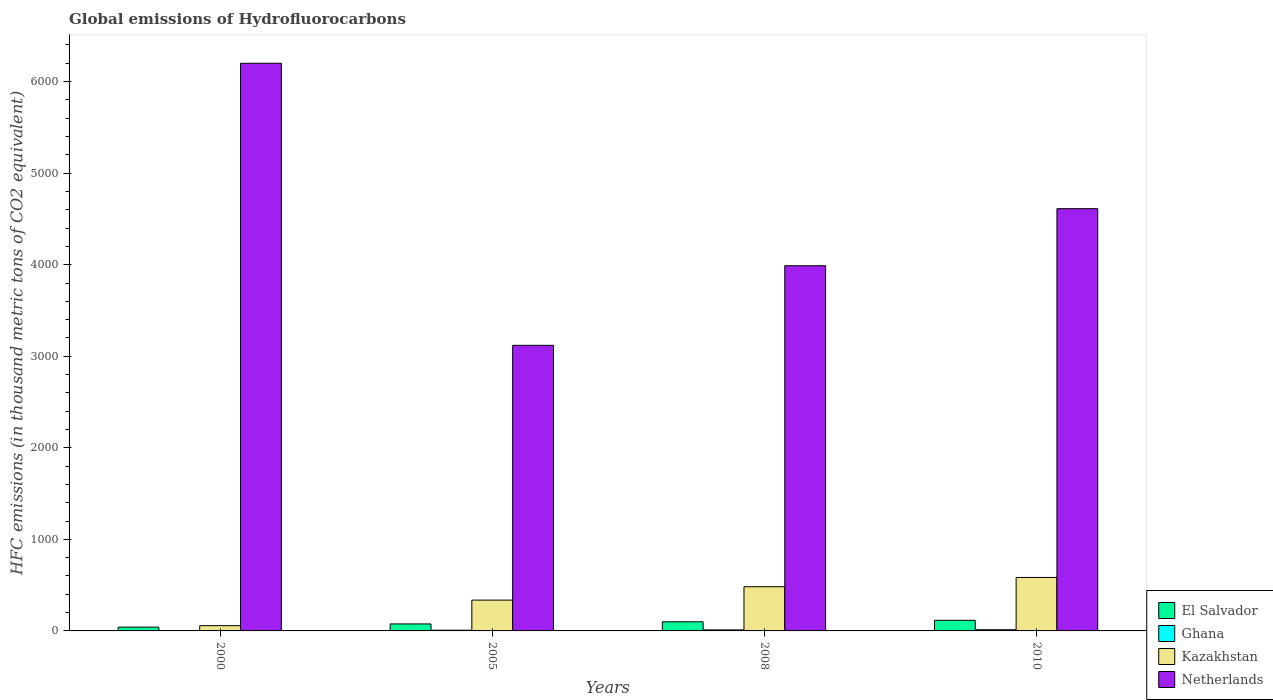How many groups of bars are there?
Offer a very short reply. 4. How many bars are there on the 4th tick from the left?
Give a very brief answer. 4. In how many cases, is the number of bars for a given year not equal to the number of legend labels?
Your answer should be very brief. 0. What is the global emissions of Hydrofluorocarbons in Netherlands in 2008?
Offer a terse response. 3988.8. Across all years, what is the minimum global emissions of Hydrofluorocarbons in El Salvador?
Your answer should be compact. 41.4. In which year was the global emissions of Hydrofluorocarbons in Kazakhstan minimum?
Provide a succinct answer. 2000. What is the total global emissions of Hydrofluorocarbons in Netherlands in the graph?
Make the answer very short. 1.79e+04. What is the difference between the global emissions of Hydrofluorocarbons in Netherlands in 2008 and that in 2010?
Keep it short and to the point. -623.2. What is the difference between the global emissions of Hydrofluorocarbons in Kazakhstan in 2000 and the global emissions of Hydrofluorocarbons in Netherlands in 2010?
Ensure brevity in your answer.  -4554.5. What is the average global emissions of Hydrofluorocarbons in Kazakhstan per year?
Ensure brevity in your answer.  365.27. In the year 2000, what is the difference between the global emissions of Hydrofluorocarbons in El Salvador and global emissions of Hydrofluorocarbons in Ghana?
Offer a terse response. 39.5. What is the ratio of the global emissions of Hydrofluorocarbons in Netherlands in 2008 to that in 2010?
Give a very brief answer. 0.86. Is the difference between the global emissions of Hydrofluorocarbons in El Salvador in 2005 and 2008 greater than the difference between the global emissions of Hydrofluorocarbons in Ghana in 2005 and 2008?
Ensure brevity in your answer.  No. What is the difference between the highest and the second highest global emissions of Hydrofluorocarbons in El Salvador?
Your answer should be very brief. 16.4. What is the difference between the highest and the lowest global emissions of Hydrofluorocarbons in Ghana?
Your response must be concise. 11.1. In how many years, is the global emissions of Hydrofluorocarbons in Kazakhstan greater than the average global emissions of Hydrofluorocarbons in Kazakhstan taken over all years?
Ensure brevity in your answer.  2. Is the sum of the global emissions of Hydrofluorocarbons in Ghana in 2000 and 2010 greater than the maximum global emissions of Hydrofluorocarbons in Netherlands across all years?
Your answer should be compact. No. What does the 3rd bar from the left in 2008 represents?
Your response must be concise. Kazakhstan. What does the 3rd bar from the right in 2010 represents?
Your answer should be very brief. Ghana. Is it the case that in every year, the sum of the global emissions of Hydrofluorocarbons in Kazakhstan and global emissions of Hydrofluorocarbons in Ghana is greater than the global emissions of Hydrofluorocarbons in El Salvador?
Make the answer very short. Yes. Are all the bars in the graph horizontal?
Ensure brevity in your answer.  No. How many legend labels are there?
Make the answer very short. 4. How are the legend labels stacked?
Your response must be concise. Vertical. What is the title of the graph?
Ensure brevity in your answer.  Global emissions of Hydrofluorocarbons. What is the label or title of the Y-axis?
Offer a terse response. HFC emissions (in thousand metric tons of CO2 equivalent). What is the HFC emissions (in thousand metric tons of CO2 equivalent) in El Salvador in 2000?
Offer a terse response. 41.4. What is the HFC emissions (in thousand metric tons of CO2 equivalent) of Ghana in 2000?
Your answer should be very brief. 1.9. What is the HFC emissions (in thousand metric tons of CO2 equivalent) in Kazakhstan in 2000?
Provide a short and direct response. 57.5. What is the HFC emissions (in thousand metric tons of CO2 equivalent) in Netherlands in 2000?
Your answer should be compact. 6200.4. What is the HFC emissions (in thousand metric tons of CO2 equivalent) of El Salvador in 2005?
Make the answer very short. 76.4. What is the HFC emissions (in thousand metric tons of CO2 equivalent) of Ghana in 2005?
Your answer should be very brief. 7.8. What is the HFC emissions (in thousand metric tons of CO2 equivalent) in Kazakhstan in 2005?
Your answer should be very brief. 336.7. What is the HFC emissions (in thousand metric tons of CO2 equivalent) in Netherlands in 2005?
Your response must be concise. 3119.5. What is the HFC emissions (in thousand metric tons of CO2 equivalent) in El Salvador in 2008?
Offer a very short reply. 99.6. What is the HFC emissions (in thousand metric tons of CO2 equivalent) of Kazakhstan in 2008?
Your answer should be very brief. 482.9. What is the HFC emissions (in thousand metric tons of CO2 equivalent) of Netherlands in 2008?
Offer a very short reply. 3988.8. What is the HFC emissions (in thousand metric tons of CO2 equivalent) in El Salvador in 2010?
Make the answer very short. 116. What is the HFC emissions (in thousand metric tons of CO2 equivalent) in Ghana in 2010?
Provide a succinct answer. 13. What is the HFC emissions (in thousand metric tons of CO2 equivalent) in Kazakhstan in 2010?
Your answer should be very brief. 584. What is the HFC emissions (in thousand metric tons of CO2 equivalent) in Netherlands in 2010?
Make the answer very short. 4612. Across all years, what is the maximum HFC emissions (in thousand metric tons of CO2 equivalent) in El Salvador?
Offer a very short reply. 116. Across all years, what is the maximum HFC emissions (in thousand metric tons of CO2 equivalent) in Kazakhstan?
Your response must be concise. 584. Across all years, what is the maximum HFC emissions (in thousand metric tons of CO2 equivalent) of Netherlands?
Offer a terse response. 6200.4. Across all years, what is the minimum HFC emissions (in thousand metric tons of CO2 equivalent) of El Salvador?
Keep it short and to the point. 41.4. Across all years, what is the minimum HFC emissions (in thousand metric tons of CO2 equivalent) of Kazakhstan?
Provide a succinct answer. 57.5. Across all years, what is the minimum HFC emissions (in thousand metric tons of CO2 equivalent) of Netherlands?
Provide a succinct answer. 3119.5. What is the total HFC emissions (in thousand metric tons of CO2 equivalent) of El Salvador in the graph?
Give a very brief answer. 333.4. What is the total HFC emissions (in thousand metric tons of CO2 equivalent) of Ghana in the graph?
Ensure brevity in your answer.  33.9. What is the total HFC emissions (in thousand metric tons of CO2 equivalent) in Kazakhstan in the graph?
Keep it short and to the point. 1461.1. What is the total HFC emissions (in thousand metric tons of CO2 equivalent) of Netherlands in the graph?
Offer a terse response. 1.79e+04. What is the difference between the HFC emissions (in thousand metric tons of CO2 equivalent) in El Salvador in 2000 and that in 2005?
Your response must be concise. -35. What is the difference between the HFC emissions (in thousand metric tons of CO2 equivalent) of Ghana in 2000 and that in 2005?
Your response must be concise. -5.9. What is the difference between the HFC emissions (in thousand metric tons of CO2 equivalent) of Kazakhstan in 2000 and that in 2005?
Your answer should be compact. -279.2. What is the difference between the HFC emissions (in thousand metric tons of CO2 equivalent) of Netherlands in 2000 and that in 2005?
Make the answer very short. 3080.9. What is the difference between the HFC emissions (in thousand metric tons of CO2 equivalent) of El Salvador in 2000 and that in 2008?
Keep it short and to the point. -58.2. What is the difference between the HFC emissions (in thousand metric tons of CO2 equivalent) in Ghana in 2000 and that in 2008?
Offer a very short reply. -9.3. What is the difference between the HFC emissions (in thousand metric tons of CO2 equivalent) in Kazakhstan in 2000 and that in 2008?
Your answer should be very brief. -425.4. What is the difference between the HFC emissions (in thousand metric tons of CO2 equivalent) in Netherlands in 2000 and that in 2008?
Ensure brevity in your answer.  2211.6. What is the difference between the HFC emissions (in thousand metric tons of CO2 equivalent) in El Salvador in 2000 and that in 2010?
Your answer should be very brief. -74.6. What is the difference between the HFC emissions (in thousand metric tons of CO2 equivalent) of Kazakhstan in 2000 and that in 2010?
Provide a succinct answer. -526.5. What is the difference between the HFC emissions (in thousand metric tons of CO2 equivalent) in Netherlands in 2000 and that in 2010?
Provide a short and direct response. 1588.4. What is the difference between the HFC emissions (in thousand metric tons of CO2 equivalent) of El Salvador in 2005 and that in 2008?
Your response must be concise. -23.2. What is the difference between the HFC emissions (in thousand metric tons of CO2 equivalent) in Kazakhstan in 2005 and that in 2008?
Keep it short and to the point. -146.2. What is the difference between the HFC emissions (in thousand metric tons of CO2 equivalent) of Netherlands in 2005 and that in 2008?
Your response must be concise. -869.3. What is the difference between the HFC emissions (in thousand metric tons of CO2 equivalent) in El Salvador in 2005 and that in 2010?
Offer a terse response. -39.6. What is the difference between the HFC emissions (in thousand metric tons of CO2 equivalent) of Kazakhstan in 2005 and that in 2010?
Your answer should be compact. -247.3. What is the difference between the HFC emissions (in thousand metric tons of CO2 equivalent) in Netherlands in 2005 and that in 2010?
Provide a short and direct response. -1492.5. What is the difference between the HFC emissions (in thousand metric tons of CO2 equivalent) of El Salvador in 2008 and that in 2010?
Provide a succinct answer. -16.4. What is the difference between the HFC emissions (in thousand metric tons of CO2 equivalent) of Ghana in 2008 and that in 2010?
Ensure brevity in your answer.  -1.8. What is the difference between the HFC emissions (in thousand metric tons of CO2 equivalent) of Kazakhstan in 2008 and that in 2010?
Keep it short and to the point. -101.1. What is the difference between the HFC emissions (in thousand metric tons of CO2 equivalent) in Netherlands in 2008 and that in 2010?
Keep it short and to the point. -623.2. What is the difference between the HFC emissions (in thousand metric tons of CO2 equivalent) of El Salvador in 2000 and the HFC emissions (in thousand metric tons of CO2 equivalent) of Ghana in 2005?
Your answer should be very brief. 33.6. What is the difference between the HFC emissions (in thousand metric tons of CO2 equivalent) of El Salvador in 2000 and the HFC emissions (in thousand metric tons of CO2 equivalent) of Kazakhstan in 2005?
Offer a very short reply. -295.3. What is the difference between the HFC emissions (in thousand metric tons of CO2 equivalent) in El Salvador in 2000 and the HFC emissions (in thousand metric tons of CO2 equivalent) in Netherlands in 2005?
Make the answer very short. -3078.1. What is the difference between the HFC emissions (in thousand metric tons of CO2 equivalent) in Ghana in 2000 and the HFC emissions (in thousand metric tons of CO2 equivalent) in Kazakhstan in 2005?
Your response must be concise. -334.8. What is the difference between the HFC emissions (in thousand metric tons of CO2 equivalent) of Ghana in 2000 and the HFC emissions (in thousand metric tons of CO2 equivalent) of Netherlands in 2005?
Ensure brevity in your answer.  -3117.6. What is the difference between the HFC emissions (in thousand metric tons of CO2 equivalent) in Kazakhstan in 2000 and the HFC emissions (in thousand metric tons of CO2 equivalent) in Netherlands in 2005?
Your answer should be compact. -3062. What is the difference between the HFC emissions (in thousand metric tons of CO2 equivalent) of El Salvador in 2000 and the HFC emissions (in thousand metric tons of CO2 equivalent) of Ghana in 2008?
Your answer should be very brief. 30.2. What is the difference between the HFC emissions (in thousand metric tons of CO2 equivalent) of El Salvador in 2000 and the HFC emissions (in thousand metric tons of CO2 equivalent) of Kazakhstan in 2008?
Your response must be concise. -441.5. What is the difference between the HFC emissions (in thousand metric tons of CO2 equivalent) in El Salvador in 2000 and the HFC emissions (in thousand metric tons of CO2 equivalent) in Netherlands in 2008?
Keep it short and to the point. -3947.4. What is the difference between the HFC emissions (in thousand metric tons of CO2 equivalent) in Ghana in 2000 and the HFC emissions (in thousand metric tons of CO2 equivalent) in Kazakhstan in 2008?
Offer a very short reply. -481. What is the difference between the HFC emissions (in thousand metric tons of CO2 equivalent) in Ghana in 2000 and the HFC emissions (in thousand metric tons of CO2 equivalent) in Netherlands in 2008?
Your answer should be compact. -3986.9. What is the difference between the HFC emissions (in thousand metric tons of CO2 equivalent) of Kazakhstan in 2000 and the HFC emissions (in thousand metric tons of CO2 equivalent) of Netherlands in 2008?
Offer a terse response. -3931.3. What is the difference between the HFC emissions (in thousand metric tons of CO2 equivalent) of El Salvador in 2000 and the HFC emissions (in thousand metric tons of CO2 equivalent) of Ghana in 2010?
Make the answer very short. 28.4. What is the difference between the HFC emissions (in thousand metric tons of CO2 equivalent) in El Salvador in 2000 and the HFC emissions (in thousand metric tons of CO2 equivalent) in Kazakhstan in 2010?
Your answer should be compact. -542.6. What is the difference between the HFC emissions (in thousand metric tons of CO2 equivalent) in El Salvador in 2000 and the HFC emissions (in thousand metric tons of CO2 equivalent) in Netherlands in 2010?
Make the answer very short. -4570.6. What is the difference between the HFC emissions (in thousand metric tons of CO2 equivalent) of Ghana in 2000 and the HFC emissions (in thousand metric tons of CO2 equivalent) of Kazakhstan in 2010?
Your response must be concise. -582.1. What is the difference between the HFC emissions (in thousand metric tons of CO2 equivalent) in Ghana in 2000 and the HFC emissions (in thousand metric tons of CO2 equivalent) in Netherlands in 2010?
Provide a succinct answer. -4610.1. What is the difference between the HFC emissions (in thousand metric tons of CO2 equivalent) of Kazakhstan in 2000 and the HFC emissions (in thousand metric tons of CO2 equivalent) of Netherlands in 2010?
Offer a terse response. -4554.5. What is the difference between the HFC emissions (in thousand metric tons of CO2 equivalent) in El Salvador in 2005 and the HFC emissions (in thousand metric tons of CO2 equivalent) in Ghana in 2008?
Your response must be concise. 65.2. What is the difference between the HFC emissions (in thousand metric tons of CO2 equivalent) of El Salvador in 2005 and the HFC emissions (in thousand metric tons of CO2 equivalent) of Kazakhstan in 2008?
Your answer should be very brief. -406.5. What is the difference between the HFC emissions (in thousand metric tons of CO2 equivalent) of El Salvador in 2005 and the HFC emissions (in thousand metric tons of CO2 equivalent) of Netherlands in 2008?
Your answer should be very brief. -3912.4. What is the difference between the HFC emissions (in thousand metric tons of CO2 equivalent) of Ghana in 2005 and the HFC emissions (in thousand metric tons of CO2 equivalent) of Kazakhstan in 2008?
Your answer should be very brief. -475.1. What is the difference between the HFC emissions (in thousand metric tons of CO2 equivalent) in Ghana in 2005 and the HFC emissions (in thousand metric tons of CO2 equivalent) in Netherlands in 2008?
Keep it short and to the point. -3981. What is the difference between the HFC emissions (in thousand metric tons of CO2 equivalent) of Kazakhstan in 2005 and the HFC emissions (in thousand metric tons of CO2 equivalent) of Netherlands in 2008?
Offer a terse response. -3652.1. What is the difference between the HFC emissions (in thousand metric tons of CO2 equivalent) in El Salvador in 2005 and the HFC emissions (in thousand metric tons of CO2 equivalent) in Ghana in 2010?
Provide a short and direct response. 63.4. What is the difference between the HFC emissions (in thousand metric tons of CO2 equivalent) in El Salvador in 2005 and the HFC emissions (in thousand metric tons of CO2 equivalent) in Kazakhstan in 2010?
Your answer should be compact. -507.6. What is the difference between the HFC emissions (in thousand metric tons of CO2 equivalent) of El Salvador in 2005 and the HFC emissions (in thousand metric tons of CO2 equivalent) of Netherlands in 2010?
Your answer should be compact. -4535.6. What is the difference between the HFC emissions (in thousand metric tons of CO2 equivalent) of Ghana in 2005 and the HFC emissions (in thousand metric tons of CO2 equivalent) of Kazakhstan in 2010?
Ensure brevity in your answer.  -576.2. What is the difference between the HFC emissions (in thousand metric tons of CO2 equivalent) of Ghana in 2005 and the HFC emissions (in thousand metric tons of CO2 equivalent) of Netherlands in 2010?
Offer a terse response. -4604.2. What is the difference between the HFC emissions (in thousand metric tons of CO2 equivalent) in Kazakhstan in 2005 and the HFC emissions (in thousand metric tons of CO2 equivalent) in Netherlands in 2010?
Give a very brief answer. -4275.3. What is the difference between the HFC emissions (in thousand metric tons of CO2 equivalent) in El Salvador in 2008 and the HFC emissions (in thousand metric tons of CO2 equivalent) in Ghana in 2010?
Make the answer very short. 86.6. What is the difference between the HFC emissions (in thousand metric tons of CO2 equivalent) in El Salvador in 2008 and the HFC emissions (in thousand metric tons of CO2 equivalent) in Kazakhstan in 2010?
Give a very brief answer. -484.4. What is the difference between the HFC emissions (in thousand metric tons of CO2 equivalent) of El Salvador in 2008 and the HFC emissions (in thousand metric tons of CO2 equivalent) of Netherlands in 2010?
Your answer should be very brief. -4512.4. What is the difference between the HFC emissions (in thousand metric tons of CO2 equivalent) in Ghana in 2008 and the HFC emissions (in thousand metric tons of CO2 equivalent) in Kazakhstan in 2010?
Your answer should be compact. -572.8. What is the difference between the HFC emissions (in thousand metric tons of CO2 equivalent) of Ghana in 2008 and the HFC emissions (in thousand metric tons of CO2 equivalent) of Netherlands in 2010?
Make the answer very short. -4600.8. What is the difference between the HFC emissions (in thousand metric tons of CO2 equivalent) of Kazakhstan in 2008 and the HFC emissions (in thousand metric tons of CO2 equivalent) of Netherlands in 2010?
Give a very brief answer. -4129.1. What is the average HFC emissions (in thousand metric tons of CO2 equivalent) of El Salvador per year?
Ensure brevity in your answer.  83.35. What is the average HFC emissions (in thousand metric tons of CO2 equivalent) of Ghana per year?
Provide a succinct answer. 8.47. What is the average HFC emissions (in thousand metric tons of CO2 equivalent) in Kazakhstan per year?
Provide a succinct answer. 365.27. What is the average HFC emissions (in thousand metric tons of CO2 equivalent) in Netherlands per year?
Keep it short and to the point. 4480.18. In the year 2000, what is the difference between the HFC emissions (in thousand metric tons of CO2 equivalent) in El Salvador and HFC emissions (in thousand metric tons of CO2 equivalent) in Ghana?
Give a very brief answer. 39.5. In the year 2000, what is the difference between the HFC emissions (in thousand metric tons of CO2 equivalent) of El Salvador and HFC emissions (in thousand metric tons of CO2 equivalent) of Kazakhstan?
Your response must be concise. -16.1. In the year 2000, what is the difference between the HFC emissions (in thousand metric tons of CO2 equivalent) of El Salvador and HFC emissions (in thousand metric tons of CO2 equivalent) of Netherlands?
Keep it short and to the point. -6159. In the year 2000, what is the difference between the HFC emissions (in thousand metric tons of CO2 equivalent) of Ghana and HFC emissions (in thousand metric tons of CO2 equivalent) of Kazakhstan?
Your answer should be compact. -55.6. In the year 2000, what is the difference between the HFC emissions (in thousand metric tons of CO2 equivalent) in Ghana and HFC emissions (in thousand metric tons of CO2 equivalent) in Netherlands?
Offer a very short reply. -6198.5. In the year 2000, what is the difference between the HFC emissions (in thousand metric tons of CO2 equivalent) of Kazakhstan and HFC emissions (in thousand metric tons of CO2 equivalent) of Netherlands?
Your answer should be compact. -6142.9. In the year 2005, what is the difference between the HFC emissions (in thousand metric tons of CO2 equivalent) of El Salvador and HFC emissions (in thousand metric tons of CO2 equivalent) of Ghana?
Make the answer very short. 68.6. In the year 2005, what is the difference between the HFC emissions (in thousand metric tons of CO2 equivalent) of El Salvador and HFC emissions (in thousand metric tons of CO2 equivalent) of Kazakhstan?
Your response must be concise. -260.3. In the year 2005, what is the difference between the HFC emissions (in thousand metric tons of CO2 equivalent) in El Salvador and HFC emissions (in thousand metric tons of CO2 equivalent) in Netherlands?
Make the answer very short. -3043.1. In the year 2005, what is the difference between the HFC emissions (in thousand metric tons of CO2 equivalent) in Ghana and HFC emissions (in thousand metric tons of CO2 equivalent) in Kazakhstan?
Your answer should be compact. -328.9. In the year 2005, what is the difference between the HFC emissions (in thousand metric tons of CO2 equivalent) of Ghana and HFC emissions (in thousand metric tons of CO2 equivalent) of Netherlands?
Keep it short and to the point. -3111.7. In the year 2005, what is the difference between the HFC emissions (in thousand metric tons of CO2 equivalent) in Kazakhstan and HFC emissions (in thousand metric tons of CO2 equivalent) in Netherlands?
Provide a short and direct response. -2782.8. In the year 2008, what is the difference between the HFC emissions (in thousand metric tons of CO2 equivalent) in El Salvador and HFC emissions (in thousand metric tons of CO2 equivalent) in Ghana?
Your response must be concise. 88.4. In the year 2008, what is the difference between the HFC emissions (in thousand metric tons of CO2 equivalent) of El Salvador and HFC emissions (in thousand metric tons of CO2 equivalent) of Kazakhstan?
Provide a short and direct response. -383.3. In the year 2008, what is the difference between the HFC emissions (in thousand metric tons of CO2 equivalent) of El Salvador and HFC emissions (in thousand metric tons of CO2 equivalent) of Netherlands?
Offer a very short reply. -3889.2. In the year 2008, what is the difference between the HFC emissions (in thousand metric tons of CO2 equivalent) in Ghana and HFC emissions (in thousand metric tons of CO2 equivalent) in Kazakhstan?
Make the answer very short. -471.7. In the year 2008, what is the difference between the HFC emissions (in thousand metric tons of CO2 equivalent) of Ghana and HFC emissions (in thousand metric tons of CO2 equivalent) of Netherlands?
Provide a short and direct response. -3977.6. In the year 2008, what is the difference between the HFC emissions (in thousand metric tons of CO2 equivalent) in Kazakhstan and HFC emissions (in thousand metric tons of CO2 equivalent) in Netherlands?
Offer a terse response. -3505.9. In the year 2010, what is the difference between the HFC emissions (in thousand metric tons of CO2 equivalent) in El Salvador and HFC emissions (in thousand metric tons of CO2 equivalent) in Ghana?
Provide a succinct answer. 103. In the year 2010, what is the difference between the HFC emissions (in thousand metric tons of CO2 equivalent) of El Salvador and HFC emissions (in thousand metric tons of CO2 equivalent) of Kazakhstan?
Give a very brief answer. -468. In the year 2010, what is the difference between the HFC emissions (in thousand metric tons of CO2 equivalent) of El Salvador and HFC emissions (in thousand metric tons of CO2 equivalent) of Netherlands?
Your response must be concise. -4496. In the year 2010, what is the difference between the HFC emissions (in thousand metric tons of CO2 equivalent) in Ghana and HFC emissions (in thousand metric tons of CO2 equivalent) in Kazakhstan?
Offer a very short reply. -571. In the year 2010, what is the difference between the HFC emissions (in thousand metric tons of CO2 equivalent) in Ghana and HFC emissions (in thousand metric tons of CO2 equivalent) in Netherlands?
Provide a short and direct response. -4599. In the year 2010, what is the difference between the HFC emissions (in thousand metric tons of CO2 equivalent) of Kazakhstan and HFC emissions (in thousand metric tons of CO2 equivalent) of Netherlands?
Your answer should be compact. -4028. What is the ratio of the HFC emissions (in thousand metric tons of CO2 equivalent) of El Salvador in 2000 to that in 2005?
Provide a succinct answer. 0.54. What is the ratio of the HFC emissions (in thousand metric tons of CO2 equivalent) in Ghana in 2000 to that in 2005?
Your answer should be very brief. 0.24. What is the ratio of the HFC emissions (in thousand metric tons of CO2 equivalent) in Kazakhstan in 2000 to that in 2005?
Make the answer very short. 0.17. What is the ratio of the HFC emissions (in thousand metric tons of CO2 equivalent) in Netherlands in 2000 to that in 2005?
Offer a very short reply. 1.99. What is the ratio of the HFC emissions (in thousand metric tons of CO2 equivalent) in El Salvador in 2000 to that in 2008?
Ensure brevity in your answer.  0.42. What is the ratio of the HFC emissions (in thousand metric tons of CO2 equivalent) in Ghana in 2000 to that in 2008?
Your answer should be very brief. 0.17. What is the ratio of the HFC emissions (in thousand metric tons of CO2 equivalent) of Kazakhstan in 2000 to that in 2008?
Keep it short and to the point. 0.12. What is the ratio of the HFC emissions (in thousand metric tons of CO2 equivalent) of Netherlands in 2000 to that in 2008?
Provide a short and direct response. 1.55. What is the ratio of the HFC emissions (in thousand metric tons of CO2 equivalent) of El Salvador in 2000 to that in 2010?
Offer a very short reply. 0.36. What is the ratio of the HFC emissions (in thousand metric tons of CO2 equivalent) of Ghana in 2000 to that in 2010?
Provide a short and direct response. 0.15. What is the ratio of the HFC emissions (in thousand metric tons of CO2 equivalent) of Kazakhstan in 2000 to that in 2010?
Your response must be concise. 0.1. What is the ratio of the HFC emissions (in thousand metric tons of CO2 equivalent) of Netherlands in 2000 to that in 2010?
Offer a very short reply. 1.34. What is the ratio of the HFC emissions (in thousand metric tons of CO2 equivalent) of El Salvador in 2005 to that in 2008?
Provide a succinct answer. 0.77. What is the ratio of the HFC emissions (in thousand metric tons of CO2 equivalent) of Ghana in 2005 to that in 2008?
Provide a short and direct response. 0.7. What is the ratio of the HFC emissions (in thousand metric tons of CO2 equivalent) of Kazakhstan in 2005 to that in 2008?
Ensure brevity in your answer.  0.7. What is the ratio of the HFC emissions (in thousand metric tons of CO2 equivalent) in Netherlands in 2005 to that in 2008?
Offer a very short reply. 0.78. What is the ratio of the HFC emissions (in thousand metric tons of CO2 equivalent) in El Salvador in 2005 to that in 2010?
Your response must be concise. 0.66. What is the ratio of the HFC emissions (in thousand metric tons of CO2 equivalent) of Kazakhstan in 2005 to that in 2010?
Make the answer very short. 0.58. What is the ratio of the HFC emissions (in thousand metric tons of CO2 equivalent) in Netherlands in 2005 to that in 2010?
Provide a succinct answer. 0.68. What is the ratio of the HFC emissions (in thousand metric tons of CO2 equivalent) of El Salvador in 2008 to that in 2010?
Make the answer very short. 0.86. What is the ratio of the HFC emissions (in thousand metric tons of CO2 equivalent) in Ghana in 2008 to that in 2010?
Make the answer very short. 0.86. What is the ratio of the HFC emissions (in thousand metric tons of CO2 equivalent) of Kazakhstan in 2008 to that in 2010?
Your answer should be compact. 0.83. What is the ratio of the HFC emissions (in thousand metric tons of CO2 equivalent) of Netherlands in 2008 to that in 2010?
Make the answer very short. 0.86. What is the difference between the highest and the second highest HFC emissions (in thousand metric tons of CO2 equivalent) of Kazakhstan?
Ensure brevity in your answer.  101.1. What is the difference between the highest and the second highest HFC emissions (in thousand metric tons of CO2 equivalent) of Netherlands?
Your response must be concise. 1588.4. What is the difference between the highest and the lowest HFC emissions (in thousand metric tons of CO2 equivalent) in El Salvador?
Your response must be concise. 74.6. What is the difference between the highest and the lowest HFC emissions (in thousand metric tons of CO2 equivalent) of Kazakhstan?
Provide a short and direct response. 526.5. What is the difference between the highest and the lowest HFC emissions (in thousand metric tons of CO2 equivalent) of Netherlands?
Provide a succinct answer. 3080.9. 